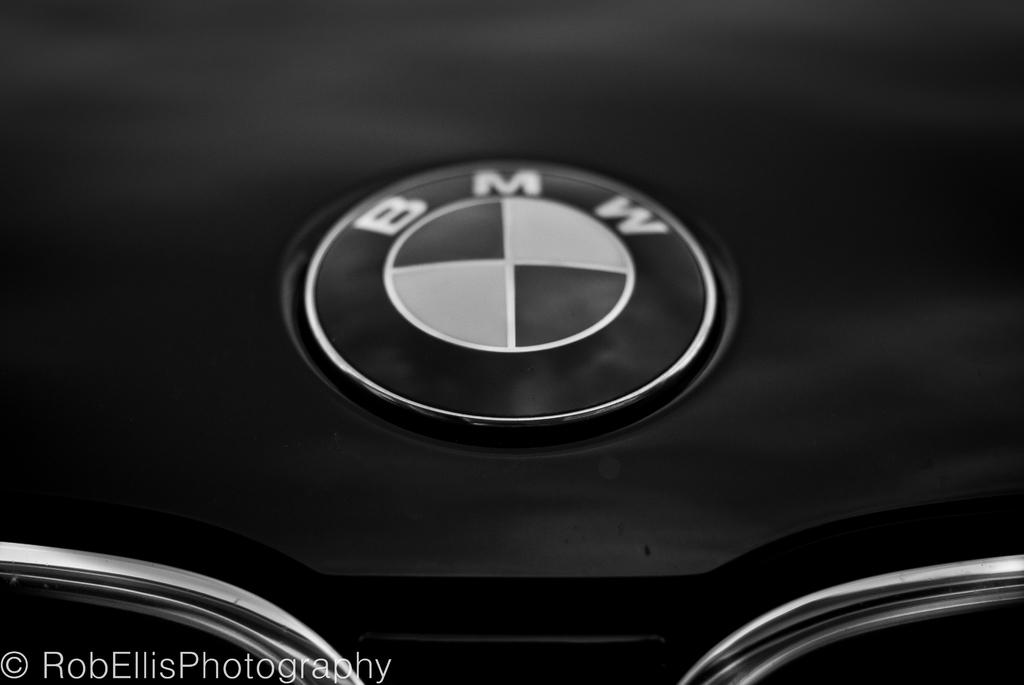What is the main feature of the image? There is a logo in the image. What is the color of the surface on which the logo is placed? The logo is on a black surface. Are there any additional elements present in the image? Yes, there is a watermark in the image. What type of science experiment is being conducted on the bed in the image? There is no bed or science experiment present in the image; it only features a logo on a black surface with a watermark. 